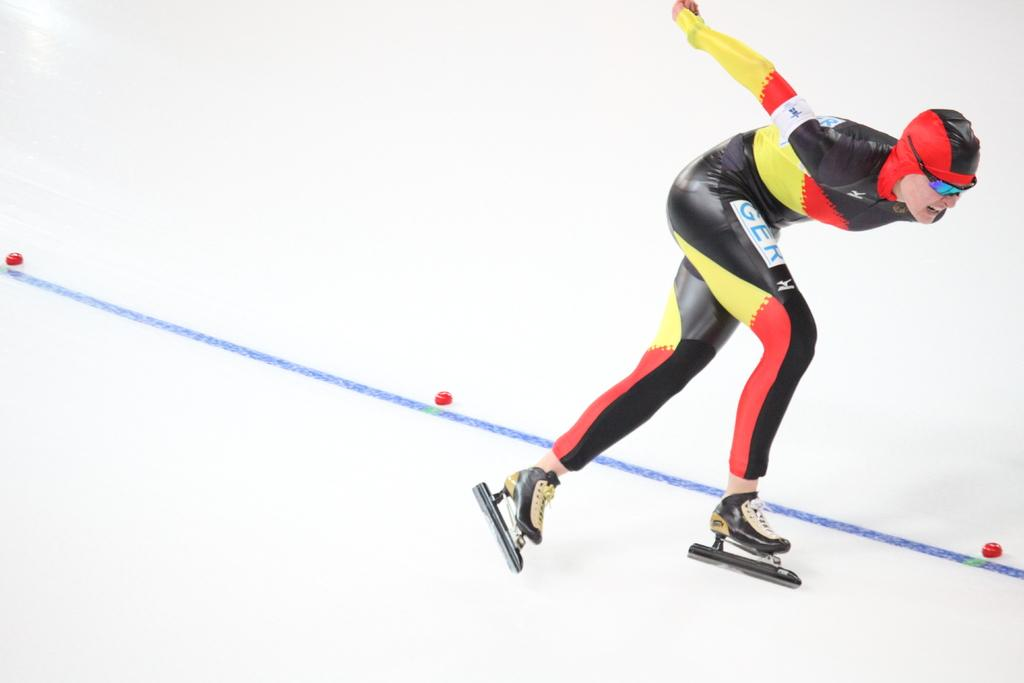What is the main subject of the image? There is a man in the image. What is the man doing in the image? The man is skating on the floor. What protective gear is the man wearing? The man is wearing goggles. What can be seen on the floor in the image? There are objects on the floor. What is the color of the background in the image? The background of the image is white in color. What type of pickle is the man holding in the image? There is no pickle present in the image. Is the man skating on lettuce in the image? No, the man is skating on the floor, not lettuce. Can you see the man floating in space in the image? No, the man is skating on the floor, not floating in space. 